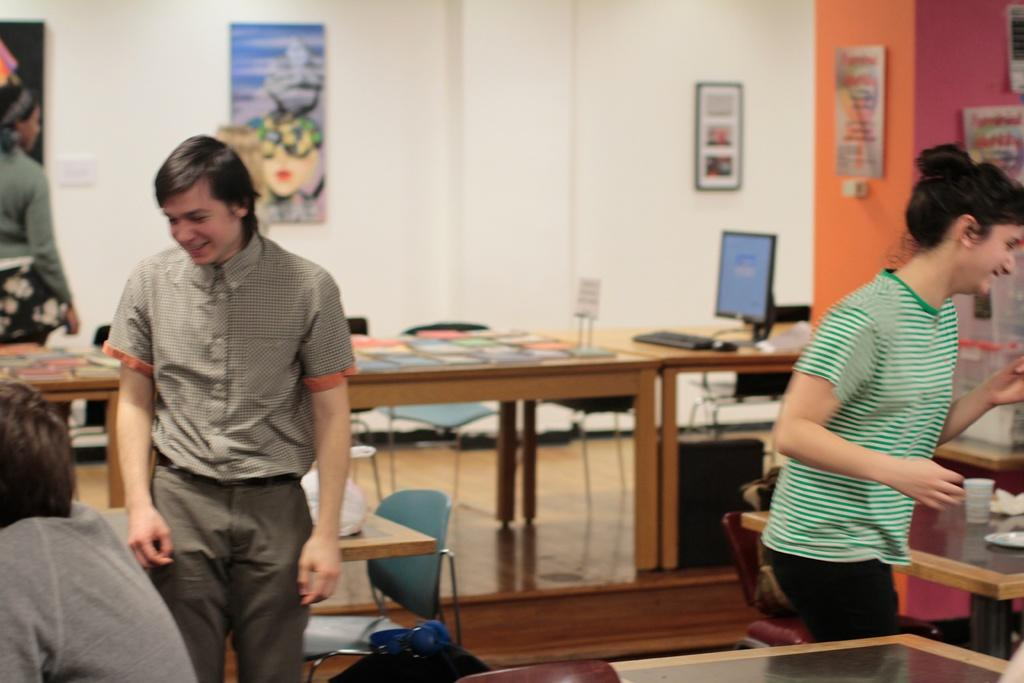How many people are in the image? There are two persons standing and smiling in the image. What is the position of the third person in the image? There is a person sitting in the image. What is on the table in the image? There are books and other objects on the table. What can be seen in the background of the image? There is a wall in the image. Can you see any flies on the arm of the person sitting in the image? There are no flies or reference to an arm in the image. 